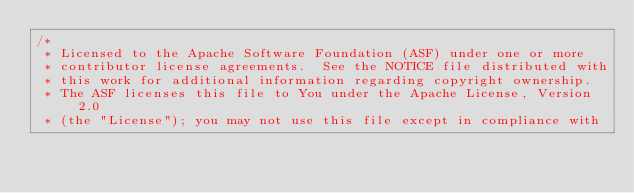Convert code to text. <code><loc_0><loc_0><loc_500><loc_500><_Go_>/*
 * Licensed to the Apache Software Foundation (ASF) under one or more
 * contributor license agreements.  See the NOTICE file distributed with
 * this work for additional information regarding copyright ownership.
 * The ASF licenses this file to You under the Apache License, Version 2.0
 * (the "License"); you may not use this file except in compliance with</code> 